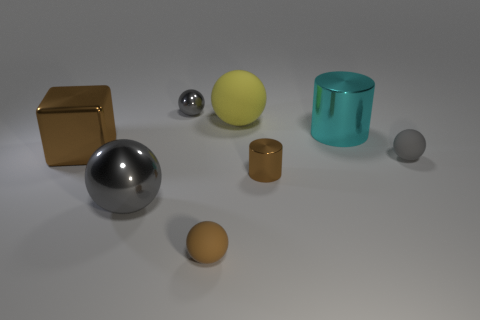Are there more big brown cubes than rubber objects?
Make the answer very short. No. How many objects are either cyan metallic objects that are to the right of the small shiny cylinder or brown metal cylinders?
Provide a succinct answer. 2. Is there a cyan metal cylinder of the same size as the cyan object?
Your answer should be very brief. No. Is the number of gray shiny spheres less than the number of shiny things?
Make the answer very short. Yes. What number of cylinders are tiny gray things or small brown metallic things?
Provide a short and direct response. 1. What number of metal objects have the same color as the tiny cylinder?
Keep it short and to the point. 1. How big is the gray object that is in front of the yellow thing and left of the big matte thing?
Your response must be concise. Large. Are there fewer large yellow matte balls behind the tiny brown cylinder than small brown rubber objects?
Make the answer very short. No. Are the tiny cylinder and the block made of the same material?
Give a very brief answer. Yes. How many objects are either brown matte things or brown metallic blocks?
Keep it short and to the point. 2. 